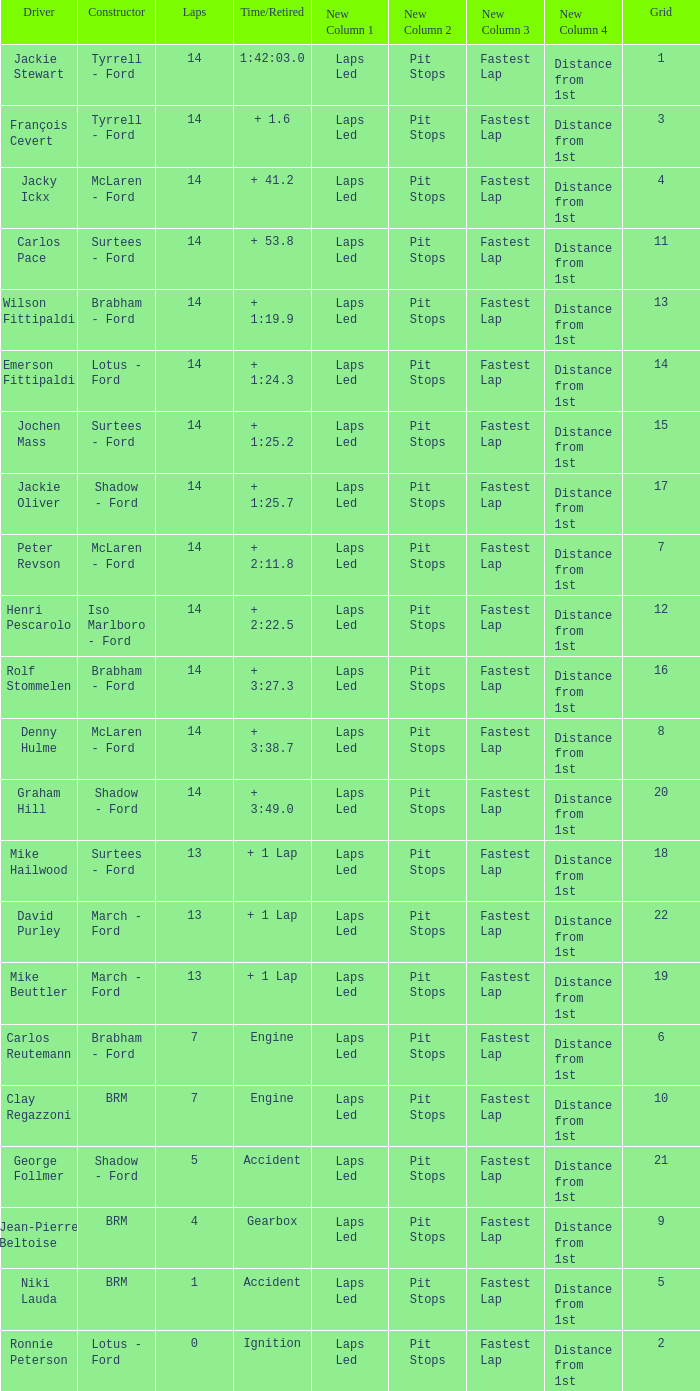What is the low lap total for a grid larger than 16 and has a Time/Retired of + 3:27.3? None. 